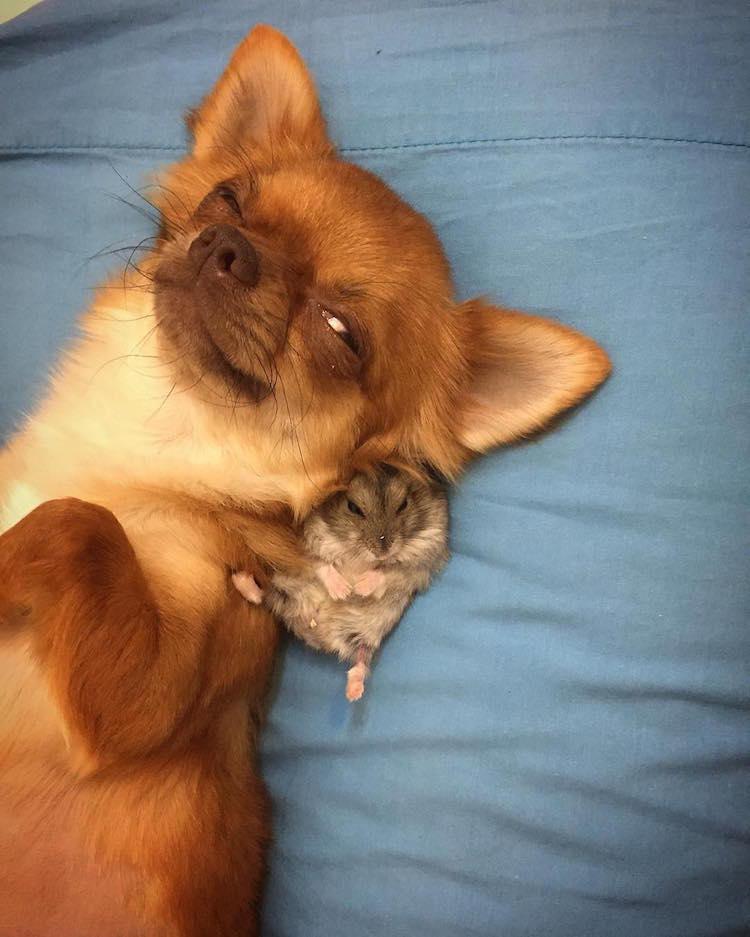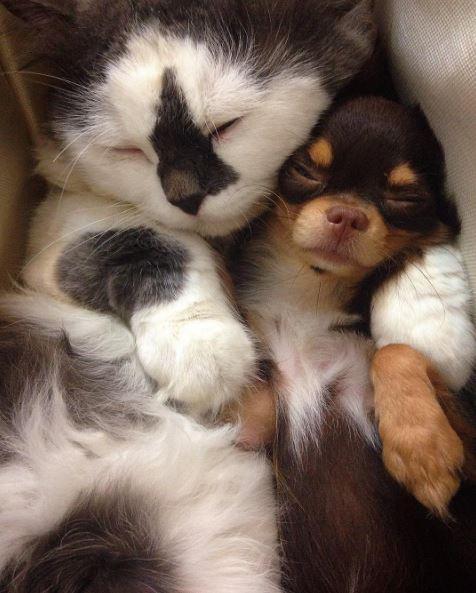The first image is the image on the left, the second image is the image on the right. For the images displayed, is the sentence "The sleeping cat is snuggling with a dog in the image on the right." factually correct? Answer yes or no. Yes. 